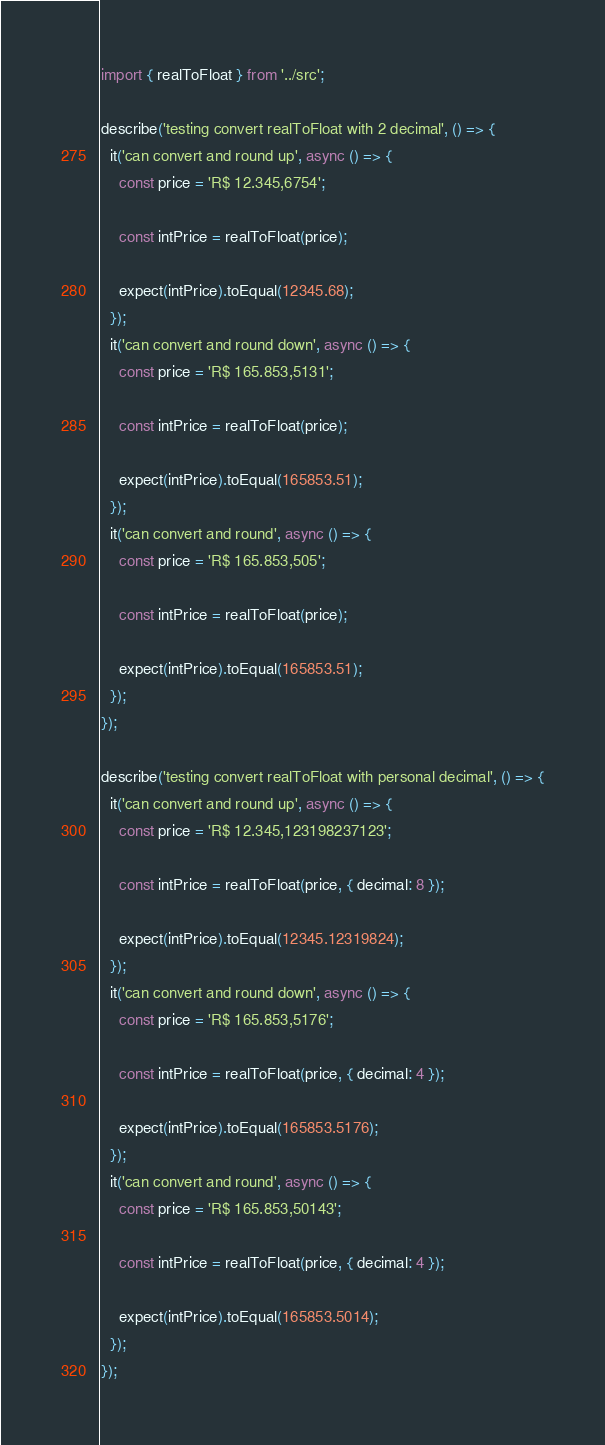<code> <loc_0><loc_0><loc_500><loc_500><_TypeScript_>import { realToFloat } from '../src';

describe('testing convert realToFloat with 2 decimal', () => {
  it('can convert and round up', async () => {
    const price = 'R$ 12.345,6754';

    const intPrice = realToFloat(price);

    expect(intPrice).toEqual(12345.68);
  });
  it('can convert and round down', async () => {
    const price = 'R$ 165.853,5131';

    const intPrice = realToFloat(price);

    expect(intPrice).toEqual(165853.51);
  });
  it('can convert and round', async () => {
    const price = 'R$ 165.853,505';

    const intPrice = realToFloat(price);

    expect(intPrice).toEqual(165853.51);
  });
});

describe('testing convert realToFloat with personal decimal', () => {
  it('can convert and round up', async () => {
    const price = 'R$ 12.345,123198237123';

    const intPrice = realToFloat(price, { decimal: 8 });

    expect(intPrice).toEqual(12345.12319824);
  });
  it('can convert and round down', async () => {
    const price = 'R$ 165.853,5176';

    const intPrice = realToFloat(price, { decimal: 4 });

    expect(intPrice).toEqual(165853.5176);
  });
  it('can convert and round', async () => {
    const price = 'R$ 165.853,50143';

    const intPrice = realToFloat(price, { decimal: 4 });

    expect(intPrice).toEqual(165853.5014);
  });
});
</code> 